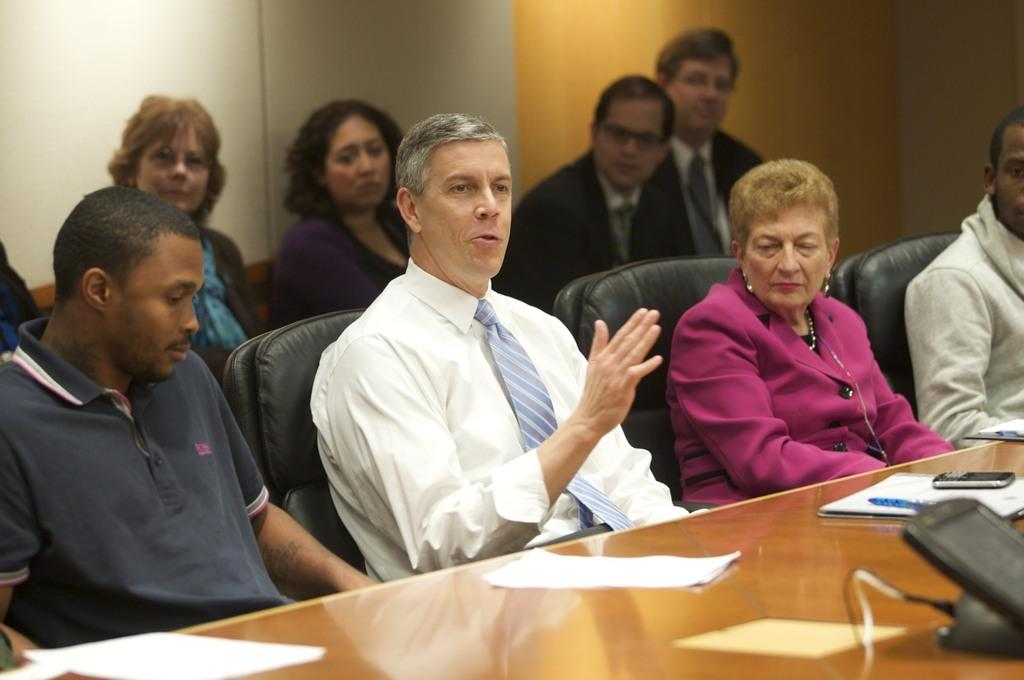How many people are in the image? There is a group of people in the image. What are the people doing in the image? The people are seated on chairs. What is on the table in front of the people? There are papers and a mobile on the table in front of the people. What else can be seen on the table in front of the people? There are other things on the table in front of the people. What scent is emanating from the papers on the table? There is no indication of a scent in the image, as it only shows a group of people seated with papers and a mobile on the table. 